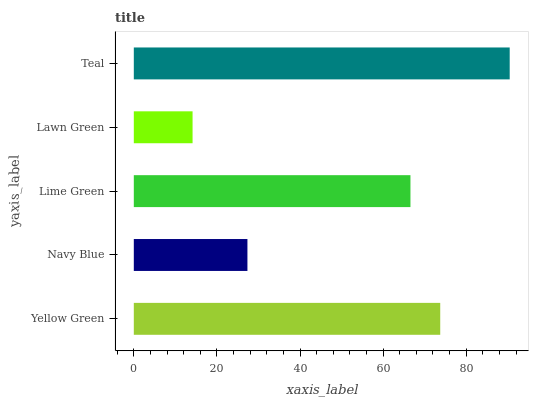Is Lawn Green the minimum?
Answer yes or no. Yes. Is Teal the maximum?
Answer yes or no. Yes. Is Navy Blue the minimum?
Answer yes or no. No. Is Navy Blue the maximum?
Answer yes or no. No. Is Yellow Green greater than Navy Blue?
Answer yes or no. Yes. Is Navy Blue less than Yellow Green?
Answer yes or no. Yes. Is Navy Blue greater than Yellow Green?
Answer yes or no. No. Is Yellow Green less than Navy Blue?
Answer yes or no. No. Is Lime Green the high median?
Answer yes or no. Yes. Is Lime Green the low median?
Answer yes or no. Yes. Is Lawn Green the high median?
Answer yes or no. No. Is Lawn Green the low median?
Answer yes or no. No. 